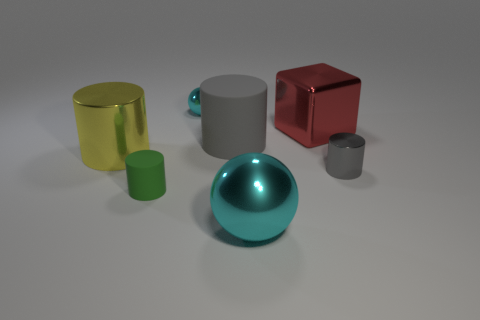What material is the big cylinder that is the same color as the tiny metal cylinder?
Give a very brief answer. Rubber. Is there anything else that has the same shape as the red object?
Provide a short and direct response. No. There is a tiny thing in front of the small shiny thing in front of the large matte cylinder that is in front of the small cyan shiny ball; what is its color?
Your answer should be compact. Green. What number of small things are metal objects or red shiny objects?
Offer a very short reply. 2. Are there an equal number of green cylinders that are on the right side of the tiny metal cylinder and small blue matte blocks?
Keep it short and to the point. Yes. Are there any gray cylinders on the left side of the tiny gray thing?
Your answer should be very brief. Yes. What number of metal objects are either small green cylinders or gray cylinders?
Your response must be concise. 1. How many cyan objects are behind the tiny green object?
Keep it short and to the point. 1. Is there a gray metallic object of the same size as the green rubber thing?
Keep it short and to the point. Yes. Is there a small matte thing that has the same color as the big block?
Offer a terse response. No. 